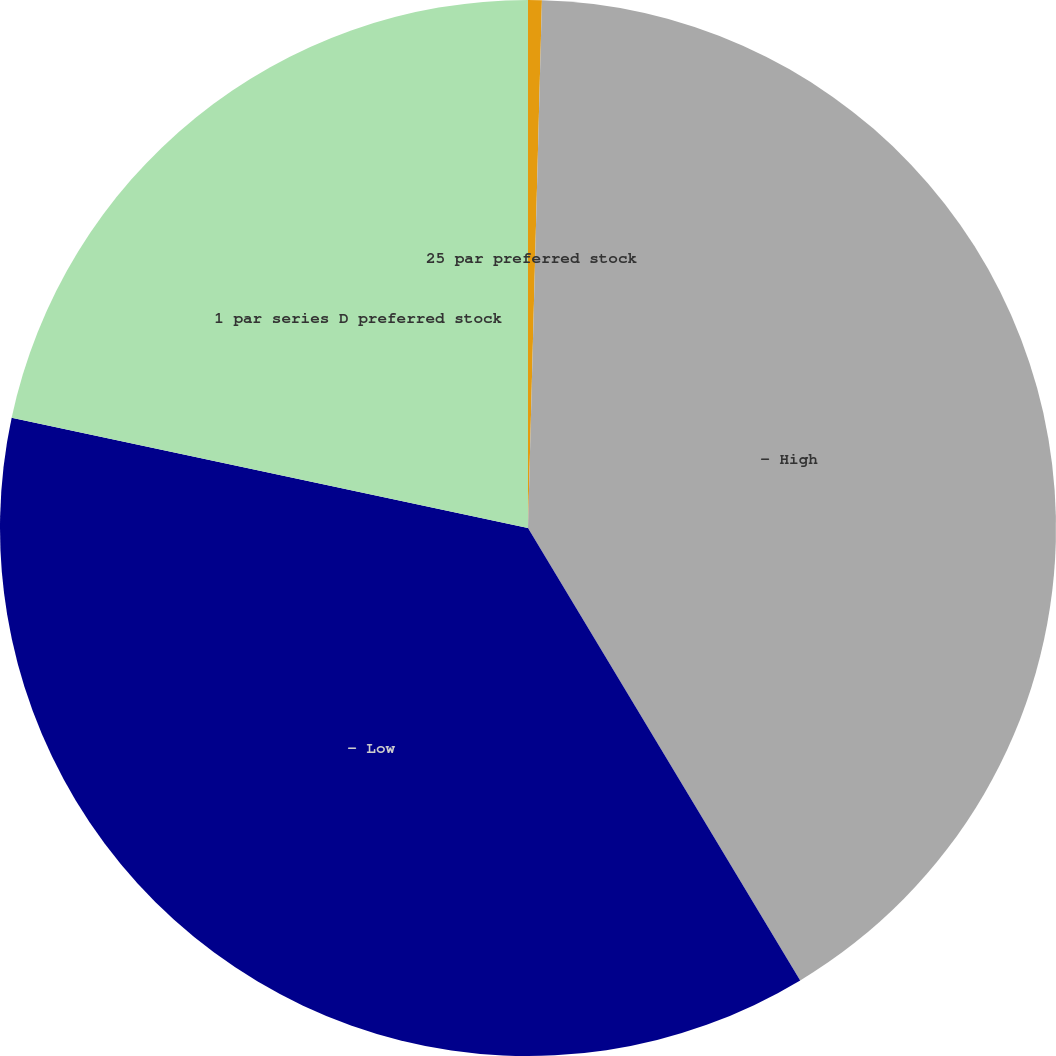Convert chart to OTSL. <chart><loc_0><loc_0><loc_500><loc_500><pie_chart><fcel>25 par preferred stock<fcel>- High<fcel>- Low<fcel>1 par series D preferred stock<nl><fcel>0.42%<fcel>40.96%<fcel>36.97%<fcel>21.65%<nl></chart> 